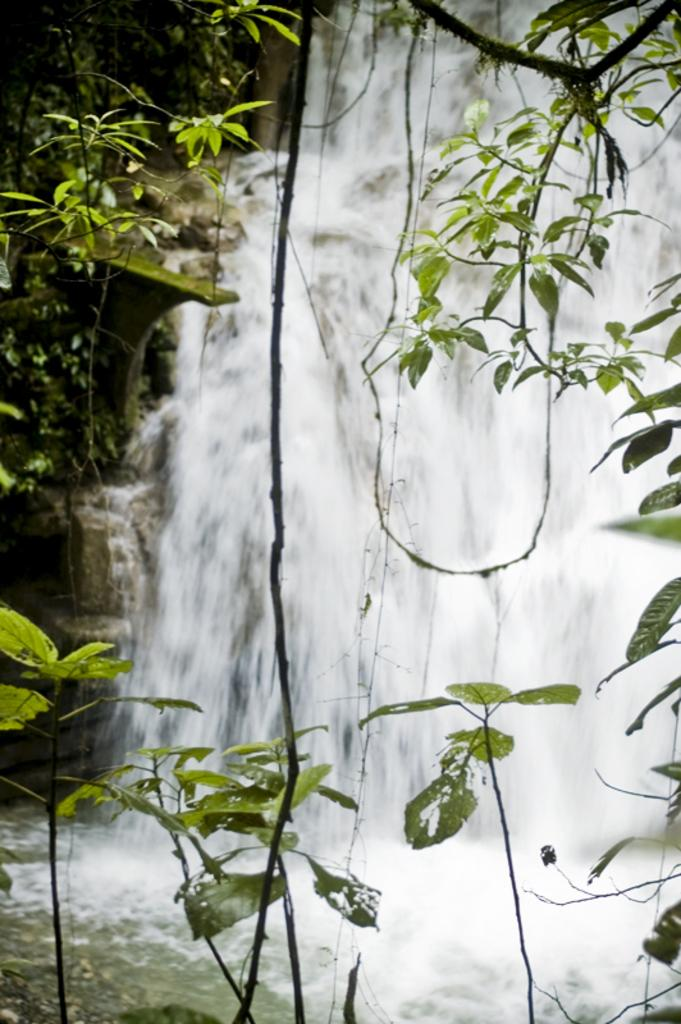What natural feature is the main subject of the picture? There is a waterfall in the picture. What type of vegetation can be seen in the picture? There are trees in the picture. How many cars are parked near the waterfall in the picture? There are no cars present in the picture; it features a waterfall and trees. What type of dolls can be seen playing on the tramp in the picture? There is no tramp or dolls present in the picture; it features a waterfall and trees. 